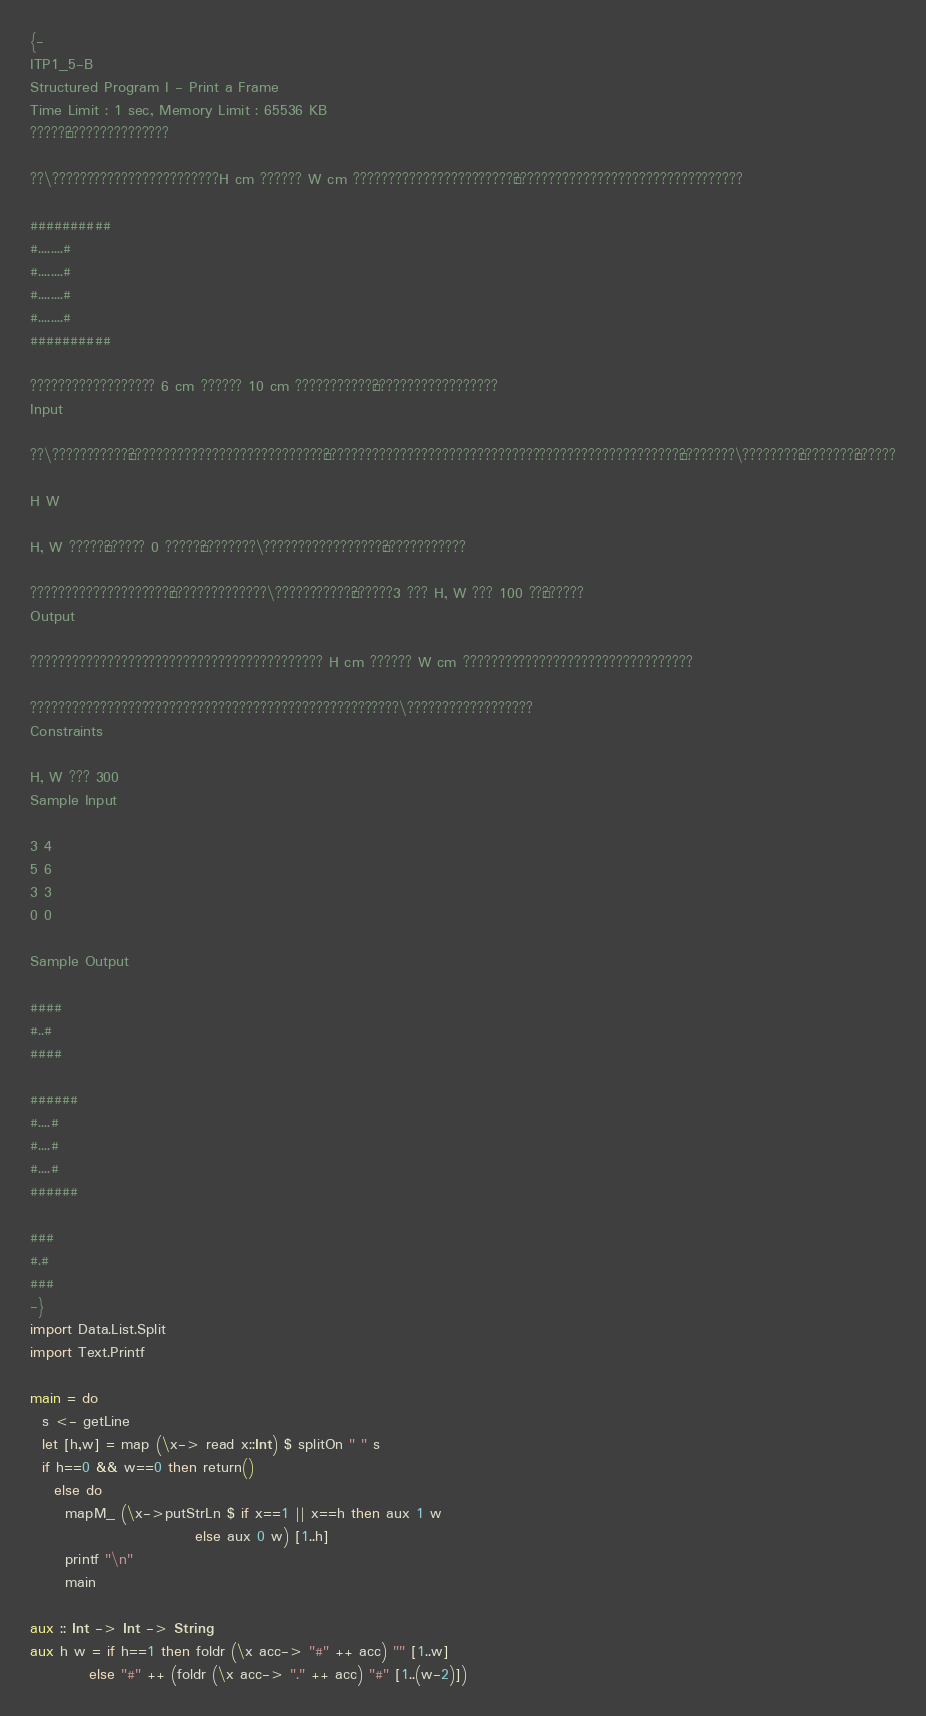Convert code to text. <code><loc_0><loc_0><loc_500><loc_500><_Haskell_>{-
ITP1_5-B
Structured Program I - Print a Frame
Time Limit : 1 sec, Memory Limit : 65536 KB
?????¬???????????????

??\????????????????????????H cm ?????? W cm ???????????????????????°?????????????????????????????????

##########
#........#
#........#
#........#
#........#
##########

?????????????????? 6 cm ?????? 10 cm ???????????¨??????????????????
Input

??\???????????°????????????????????????????§???????????????????????????????????????????????????¢????????\????????¨????????§??????

H W

H, W ?????¨?????? 0 ?????¨????????\?????????????????¨????????????

????????????????????¨??????????????\???????????¶??????3 ??? H, W ??? 100 ??§??????
Output

?????????????????????????????????????????? H cm ?????? W cm ?????????????????????????????????

?????????????????????????????????????????????????????\??????????????????
Constraints

H, W ??? 300
Sample Input

3 4
5 6
3 3
0 0

Sample Output

####
#..#
####

######
#....#
#....#
#....#
######

###
#.#
###
-}
import Data.List.Split
import Text.Printf

main = do
  s <- getLine
  let [h,w] = map (\x-> read x::Int) $ splitOn " " s
  if h==0 && w==0 then return()
    else do
      mapM_ (\x->putStrLn $ if x==1 || x==h then aux 1 w
                            else aux 0 w) [1..h]
      printf "\n"
      main

aux :: Int -> Int -> String
aux h w = if h==1 then foldr (\x acc-> "#" ++ acc) "" [1..w]
          else "#" ++ (foldr (\x acc-> "." ++ acc) "#" [1..(w-2)])</code> 